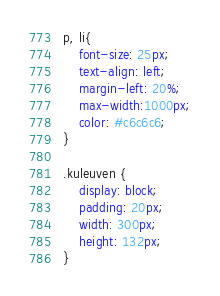<code> <loc_0><loc_0><loc_500><loc_500><_CSS_>

p, li{
    font-size: 25px;
    text-align: left;
    margin-left: 20%;
    max-width:1000px;
    color: #c6c6c6;
}

.kuleuven {
    display: block;
    padding: 20px;
    width: 300px;
    height: 132px;
}
</code> 